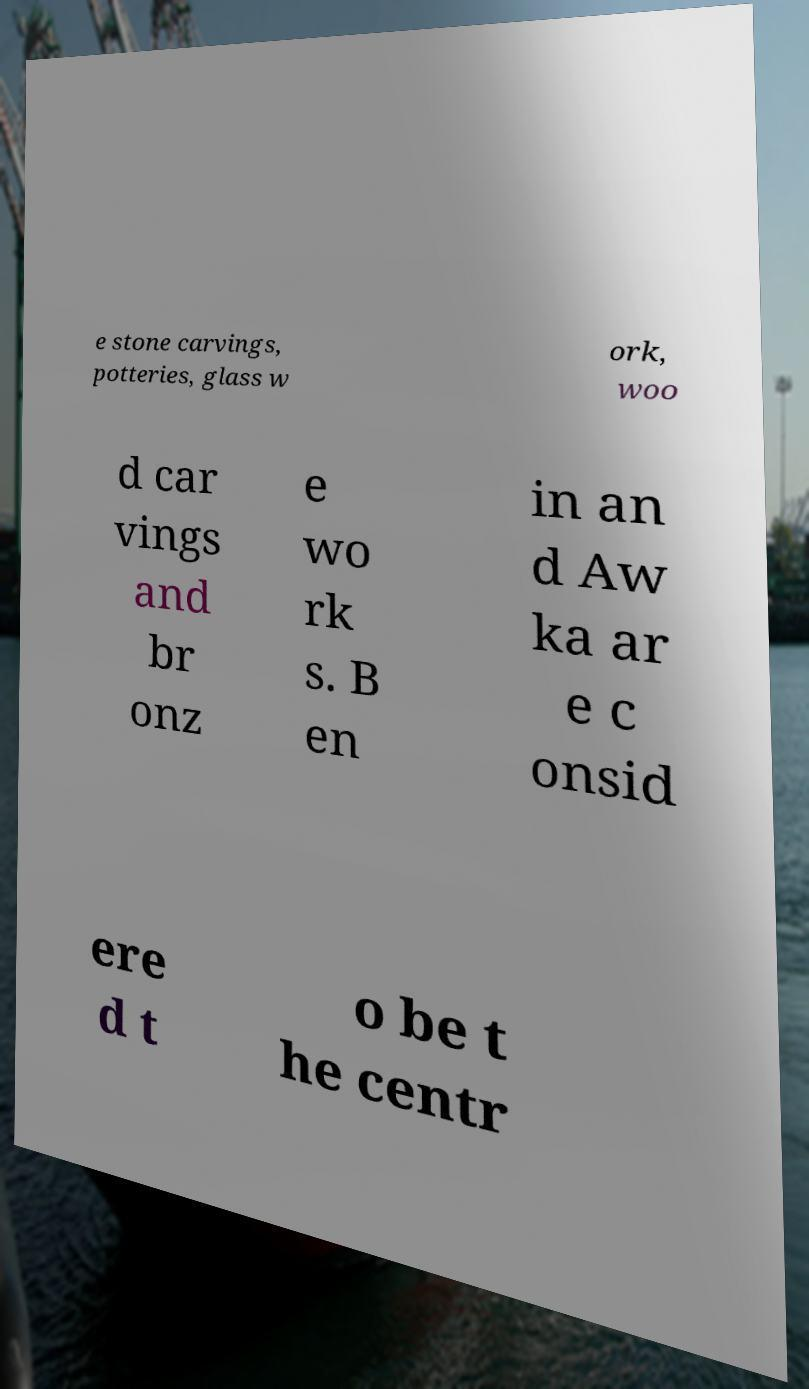Can you read and provide the text displayed in the image?This photo seems to have some interesting text. Can you extract and type it out for me? e stone carvings, potteries, glass w ork, woo d car vings and br onz e wo rk s. B en in an d Aw ka ar e c onsid ere d t o be t he centr 